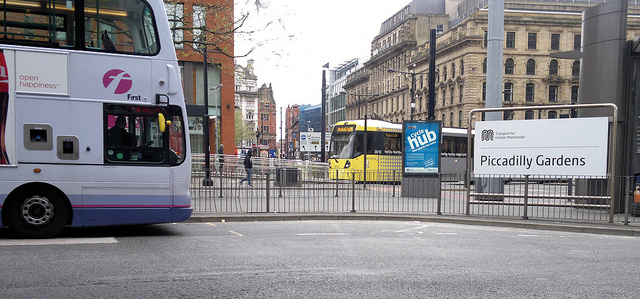Is there anything unique or interesting in the image that you notice? One interesting aspect is the contrast between mobility and stillness. Although buses are meant for travel, they are stationary in this scene, likely waiting at a traffic signal or a bus stop. The pedestrian barriers also add a sense of order to the urban space. 